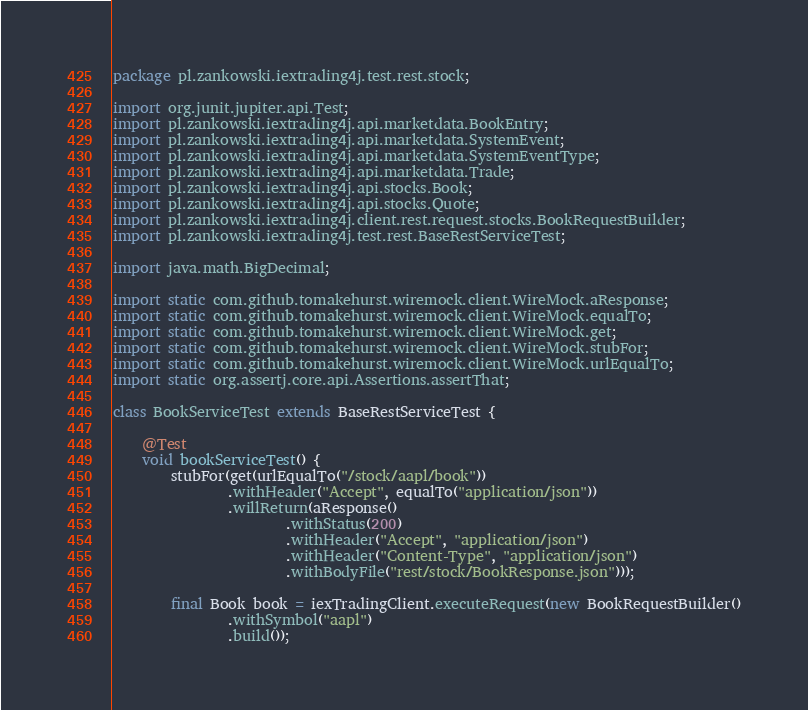Convert code to text. <code><loc_0><loc_0><loc_500><loc_500><_Java_>package pl.zankowski.iextrading4j.test.rest.stock;

import org.junit.jupiter.api.Test;
import pl.zankowski.iextrading4j.api.marketdata.BookEntry;
import pl.zankowski.iextrading4j.api.marketdata.SystemEvent;
import pl.zankowski.iextrading4j.api.marketdata.SystemEventType;
import pl.zankowski.iextrading4j.api.marketdata.Trade;
import pl.zankowski.iextrading4j.api.stocks.Book;
import pl.zankowski.iextrading4j.api.stocks.Quote;
import pl.zankowski.iextrading4j.client.rest.request.stocks.BookRequestBuilder;
import pl.zankowski.iextrading4j.test.rest.BaseRestServiceTest;

import java.math.BigDecimal;

import static com.github.tomakehurst.wiremock.client.WireMock.aResponse;
import static com.github.tomakehurst.wiremock.client.WireMock.equalTo;
import static com.github.tomakehurst.wiremock.client.WireMock.get;
import static com.github.tomakehurst.wiremock.client.WireMock.stubFor;
import static com.github.tomakehurst.wiremock.client.WireMock.urlEqualTo;
import static org.assertj.core.api.Assertions.assertThat;

class BookServiceTest extends BaseRestServiceTest {

    @Test
    void bookServiceTest() {
        stubFor(get(urlEqualTo("/stock/aapl/book"))
                .withHeader("Accept", equalTo("application/json"))
                .willReturn(aResponse()
                        .withStatus(200)
                        .withHeader("Accept", "application/json")
                        .withHeader("Content-Type", "application/json")
                        .withBodyFile("rest/stock/BookResponse.json")));

        final Book book = iexTradingClient.executeRequest(new BookRequestBuilder()
                .withSymbol("aapl")
                .build());
</code> 